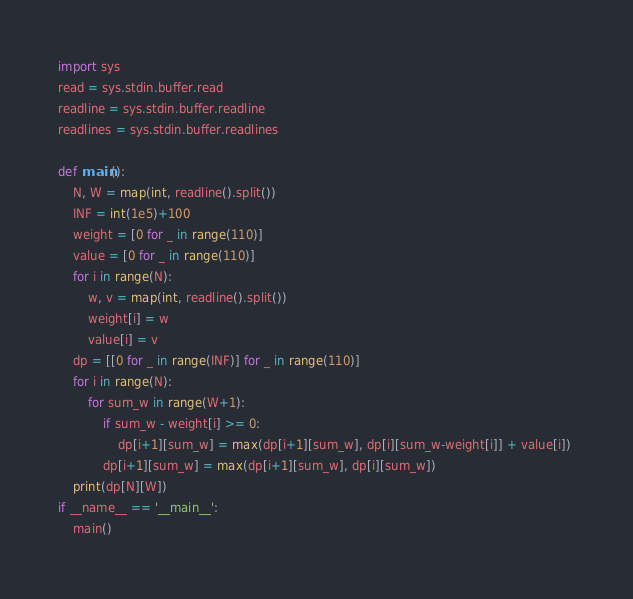Convert code to text. <code><loc_0><loc_0><loc_500><loc_500><_Python_>import sys
read = sys.stdin.buffer.read
readline = sys.stdin.buffer.readline
readlines = sys.stdin.buffer.readlines
 
def main():
    N, W = map(int, readline().split())
    INF = int(1e5)+100
    weight = [0 for _ in range(110)]
    value = [0 for _ in range(110)] 
    for i in range(N):
        w, v = map(int, readline().split())
        weight[i] = w
        value[i] = v
    dp = [[0 for _ in range(INF)] for _ in range(110)]
    for i in range(N):
        for sum_w in range(W+1):
            if sum_w - weight[i] >= 0:
                dp[i+1][sum_w] = max(dp[i+1][sum_w], dp[i][sum_w-weight[i]] + value[i]) 
            dp[i+1][sum_w] = max(dp[i+1][sum_w], dp[i][sum_w])
    print(dp[N][W])
if __name__ == '__main__':
    main()
</code> 